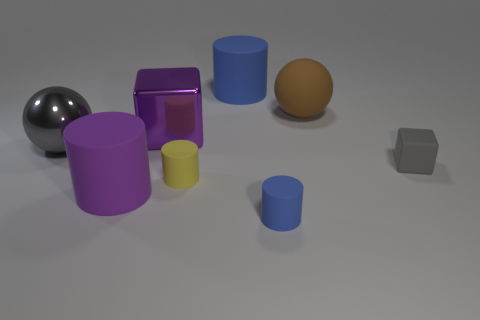Add 1 large metal blocks. How many objects exist? 9 Subtract all small yellow cylinders. How many cylinders are left? 3 Subtract all purple cylinders. How many cylinders are left? 3 Subtract all spheres. How many objects are left? 6 Subtract 1 spheres. How many spheres are left? 1 Subtract all red cubes. Subtract all green balls. How many cubes are left? 2 Subtract all cyan spheres. How many gray cylinders are left? 0 Subtract all big green metal cylinders. Subtract all gray spheres. How many objects are left? 7 Add 3 small gray things. How many small gray things are left? 4 Add 5 big green blocks. How many big green blocks exist? 5 